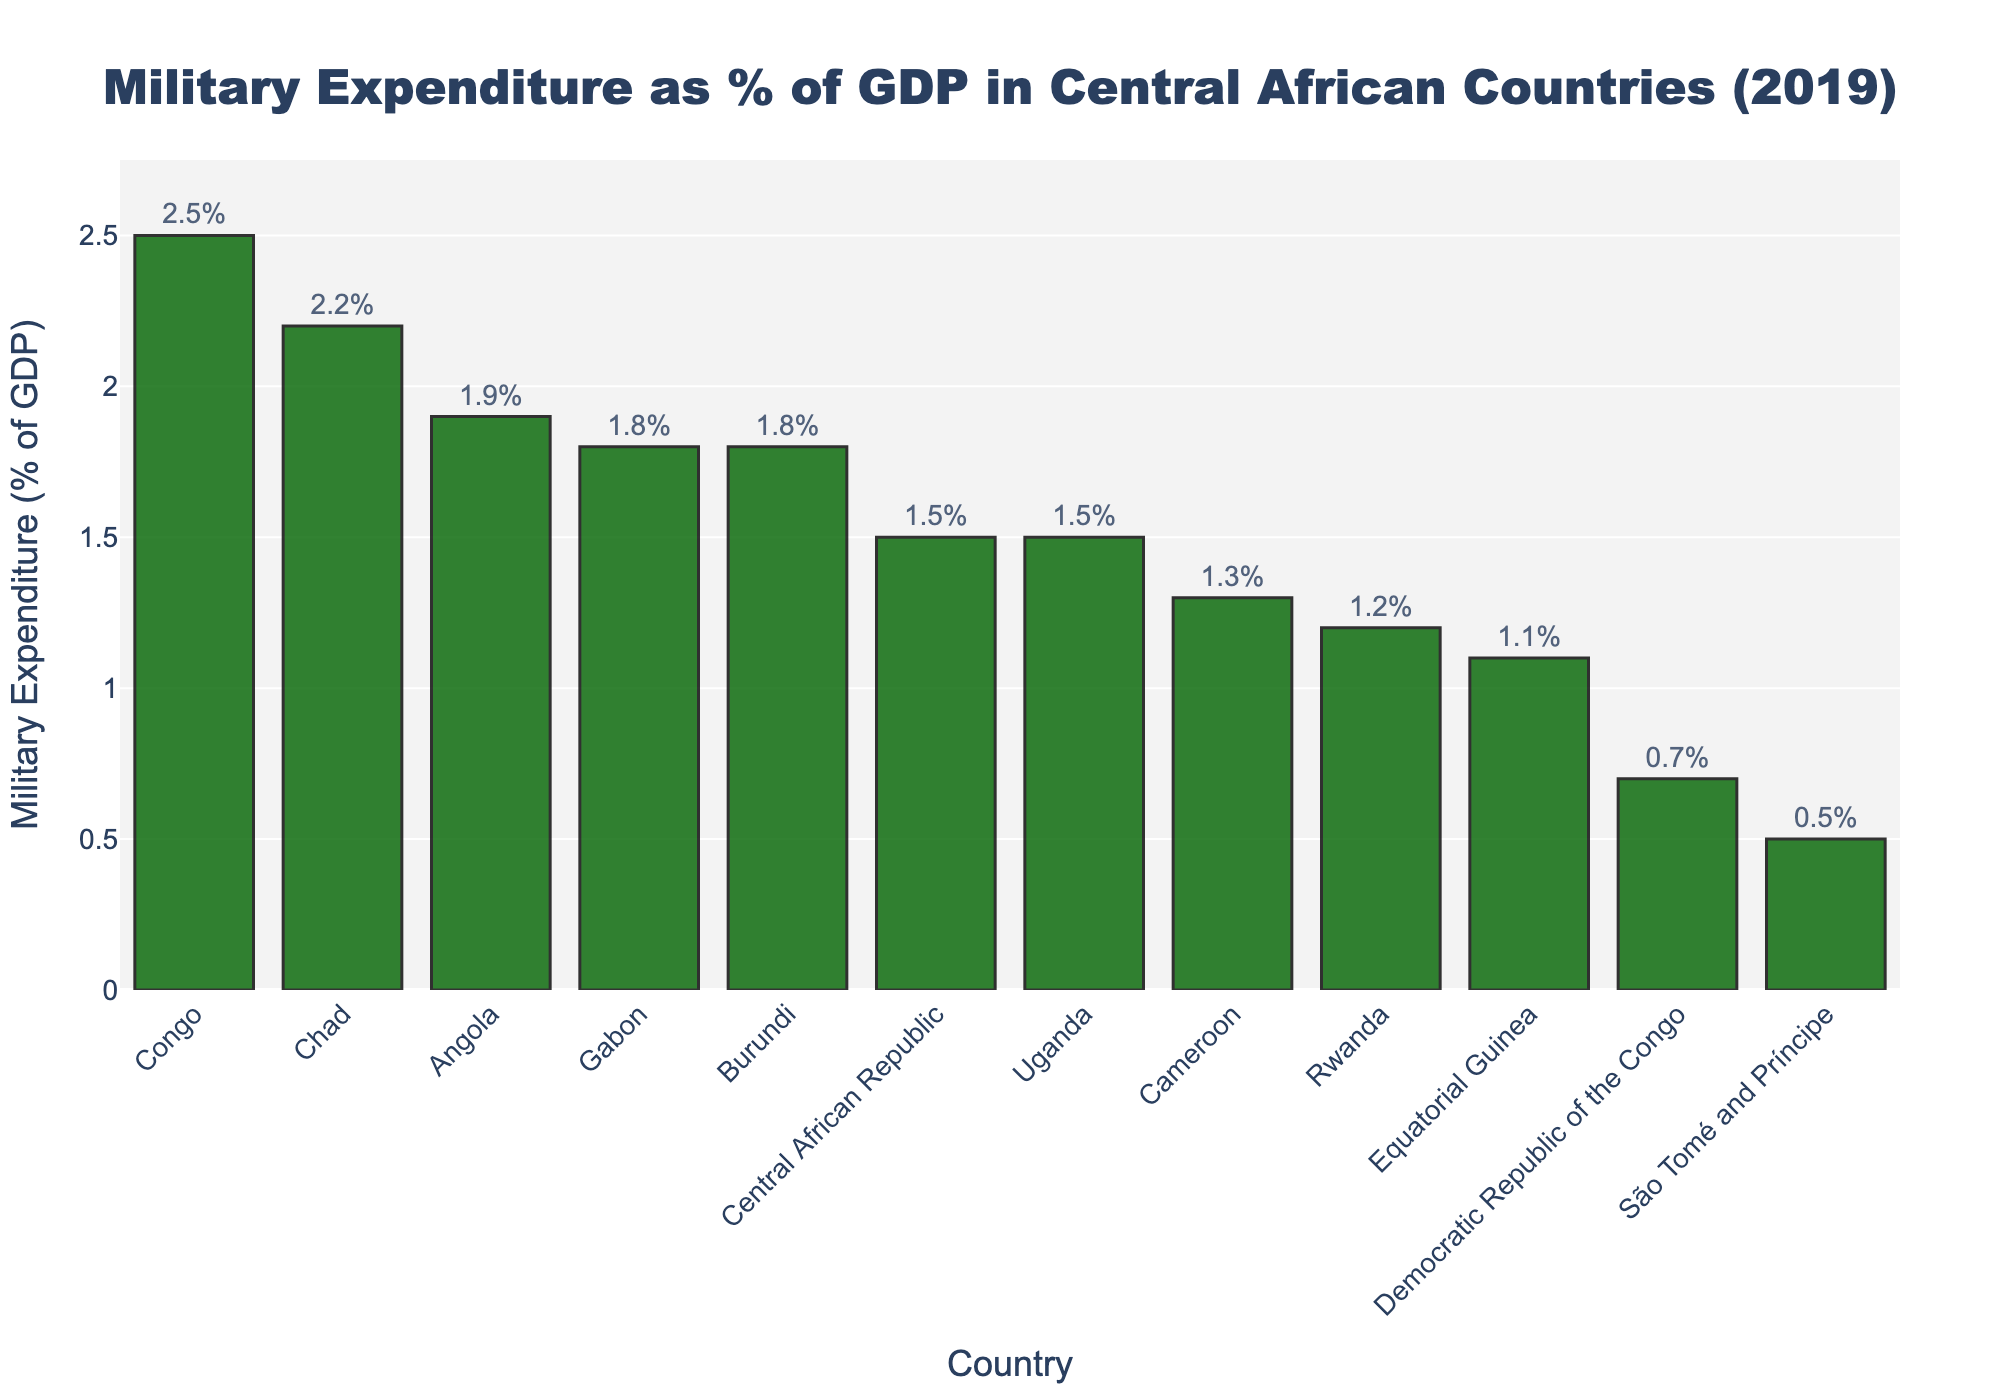Which country has the highest military expenditure as a percentage of GDP? By examining the height of the bars in the figure, the Congo has the highest military expenditure with a value of 2.5%.
Answer: Congo Which country has the lowest military expenditure as a percentage of GDP? By referring to the shortest bar in the chart, São Tomé and Príncipe has the lowest military expenditure at 0.5%.
Answer: São Tomé and Príncipe What is the difference in military expenditure as a percentage of GDP between Gabon and Cameroon? Gabon's military expenditure is 1.8% and Cameroon's is 1.3%. The difference is 1.8 - 1.3 = 0.5%.
Answer: 0.5% Which countries have a military expenditure as a percentage of GDP greater than 2%? Examining the figure, Chad (2.2%) and Congo (2.5%) have a military expenditure greater than 2%.
Answer: Chad, Congo What is the average military expenditure as a percentage of GDP for all the countries listed? Sum all the percentages and divide by the number of countries: (1.3 + 1.5 + 2.2 + 2.5 + 0.7 + 1.1 + 1.8 + 0.5 + 1.9 + 1.8 + 1.2 + 1.5) / 12 = 1.45%.
Answer: 1.45% Which countries have equal military expenditure percentages? Examining the figure, Gabon and Burundi both have a military expenditure of 1.8%.
Answer: Gabon, Burundi What is the total military expenditure percentage for the top three countries? The top three countries by military expenditure are Congo (2.5%), Chad (2.2%), and Angola (1.9%). Summing these gives 2.5 + 2.2 + 1.9 = 6.6%.
Answer: 6.6% How much higher is Congo's military expenditure percentage compared to the Democratic Republic of the Congo? Congo has a military expenditure of 2.5%, and the Democratic Republic of the Congo has 0.7%. The difference is 2.5 - 0.7 = 1.8%.
Answer: 1.8% List the countries with military expenditure percentages below the average. The average military expenditure percentage is 1.45%. Countries below this average are São Tomé and Príncipe (0.5%), Democratic Republic of the Congo (0.7%), Equatorial Guinea (1.1%), Rwanda (1.2%), and Cameroon (1.3%).
Answer: São Tomé and Príncipe, Democratic Republic of the Congo, Equatorial Guinea, Rwanda, Cameroon 